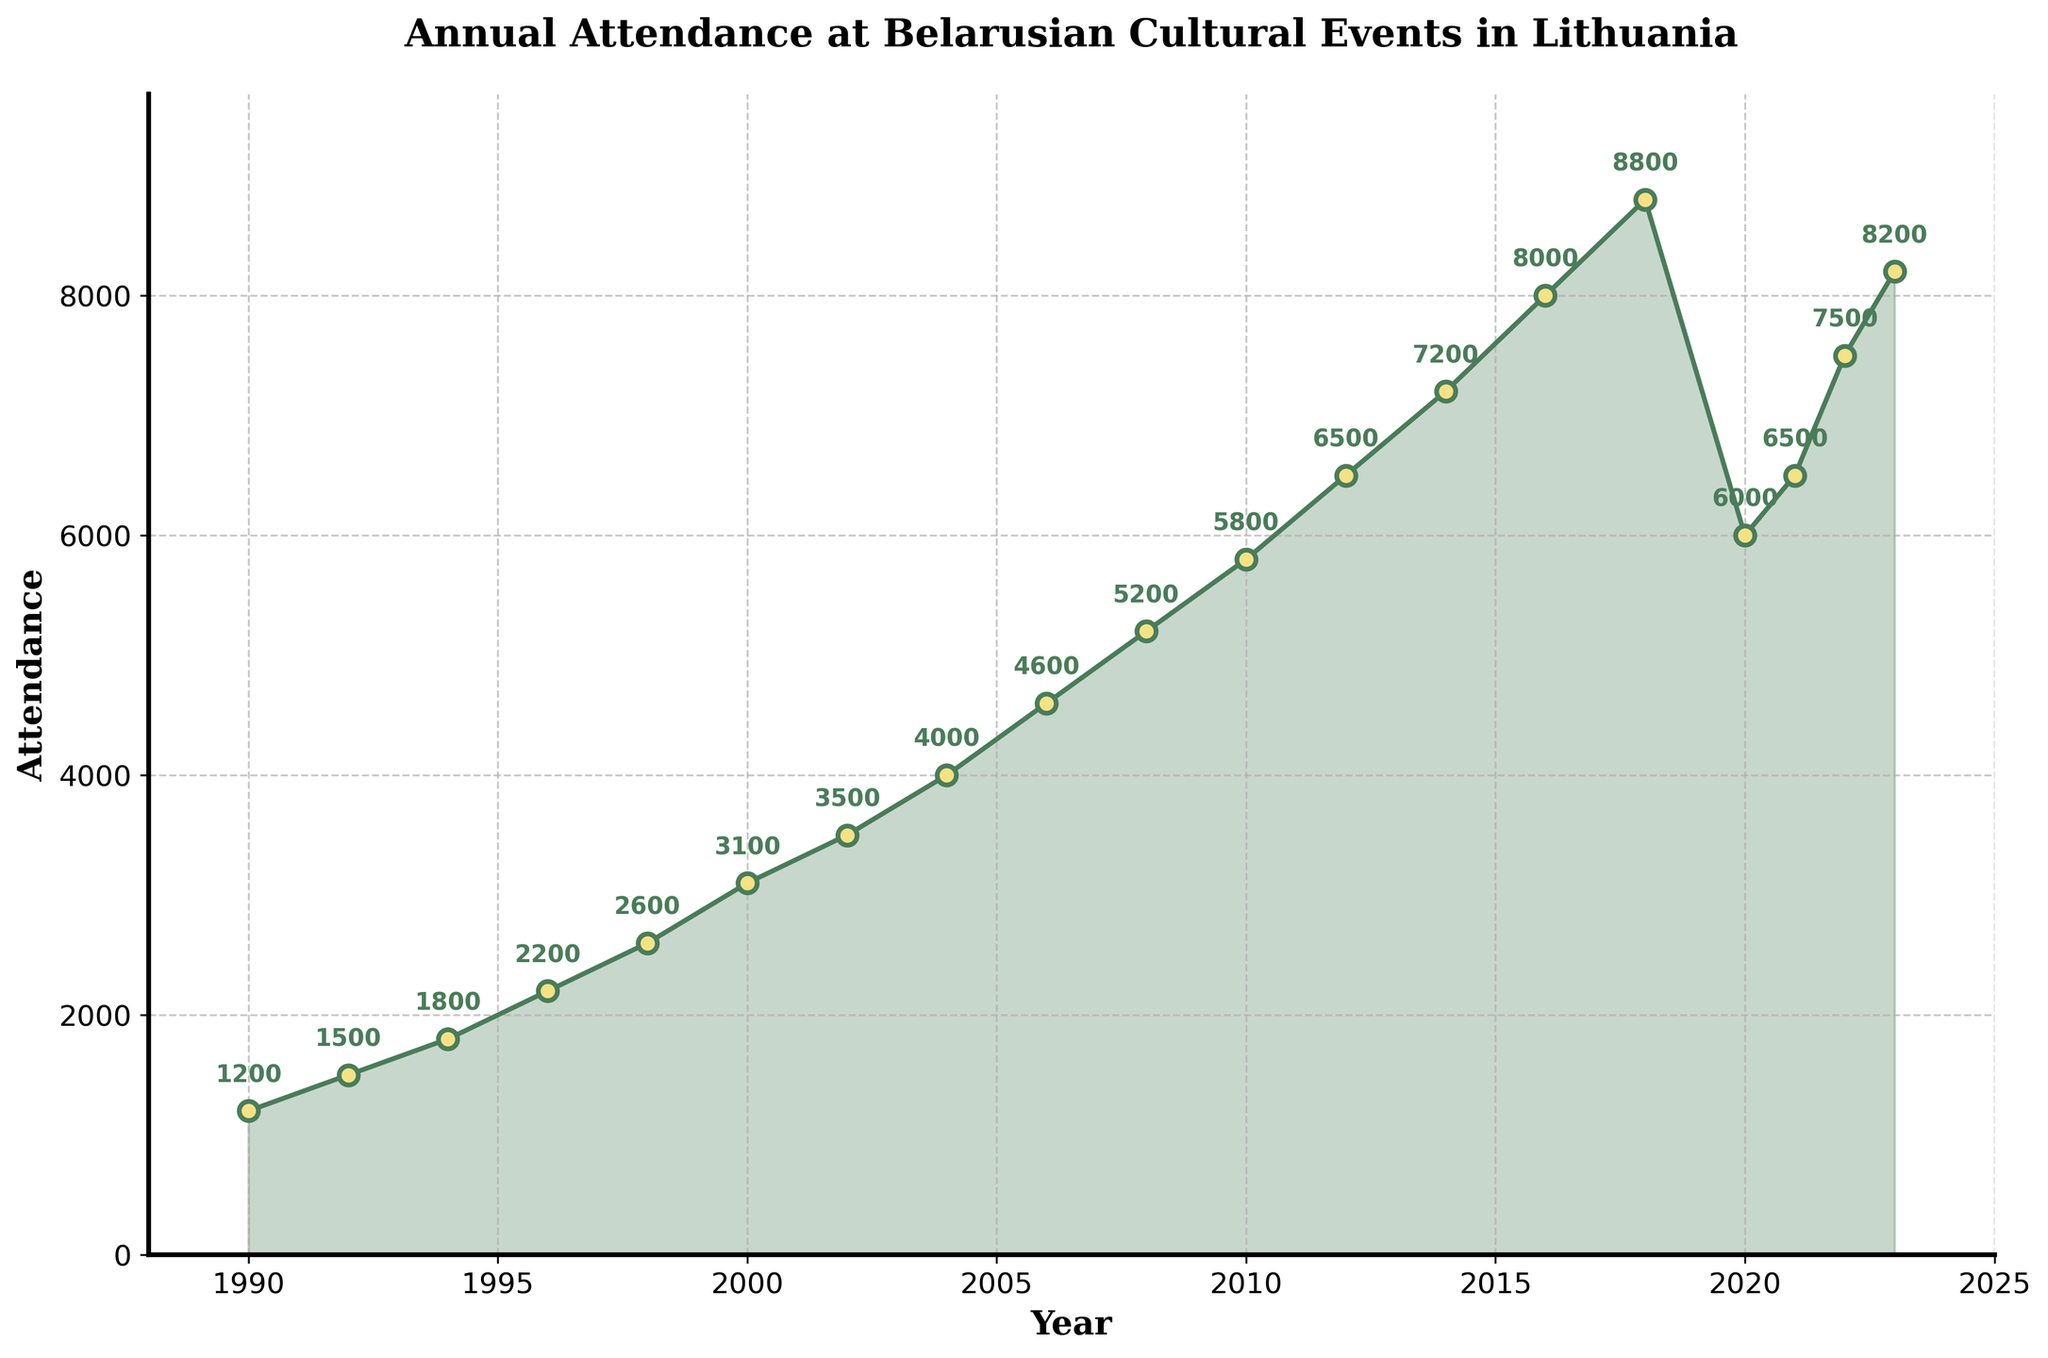What's the highest recorded annual attendance at Belarusian cultural events? Looking at the graph, the highest attendance recorded is in 2018 with 8800 attendees.
Answer: 8800 How did the attendance change from 1990 to 2000? In 1990, the attendance was 1200. In 2000, it increased to 3100. The change in attendance is calculated by subtracting 1200 from 3100. Therefore, the increase is 3100 - 1200 = 1900.
Answer: 1900 Between which consecutive years did the attendance see the greatest increase? Comparing the differences between consecutive data points: 1990-1992: 300, 1992-1994: 300, 1994-1996: 400, 1996-1998: 400, 1998-2000: 500, 2000-2002: 400, 2002-2004: 500, 2004-2006: 600, 2006-2008: 600, 2008-2010: 600, 2010-2012: 700, 2012-2014: 700, 2014-2016: 800, 2016-2018: 800, 2018-2020: -2800, 2020-2021: 500, 2021-2022: 1000, 2022-2023: 700. The greatest increase is between 2016 and 2018.
Answer: 2016-2018 What is the average attendance from 2010 to 2020? The attendance from 2010 to 2020 is: 5800, 6500, 7200, 8000, 8800, 6000. The sum of these values is 42300. There are 6 data points, so the average attendance is 42300 / 6 ≈ 7050.
Answer: 7050 What was the attendance in the year 2020, and how does it compare to the previous year? In 2020, the attendance was 6000. In the previous year, 2018, the attendance was 8800. The difference is 8800 - 6000 = 2800. The attendance decreased by 2800.
Answer: Decreased by 2800 Did the attendance in 2022 surpass the maximum attendance recorded before 2012? Before 2012, the highest attendance was 5800 in 2010. In 2022, the attendance was 7500, which is greater than 5800. Thus, the 2022 attendance surpassed the maximum attendance recorded before 2012.
Answer: Yes On average, how much did the attendance increase per year from 1990 to 2018? The total increase from 1990 to 2018 is calculated by subtracting the attendance in 1990 from that in 2018: 8800 - 1200 = 7600. The number of years between 1990 and 2018 is 28. Therefore, the average increase per year is 7600 / 28 ≈ 271.43.
Answer: ≈ 271.43 Which year experienced a decline in attendance following steady growth, and what was the decline? After steady growth until 2018, the year 2020 experienced a decline. The attendance dropped from 8800 in 2018 to 6000 in 2020. The decline was 8800 - 6000 = 2800.
Answer: 2020, 2800 